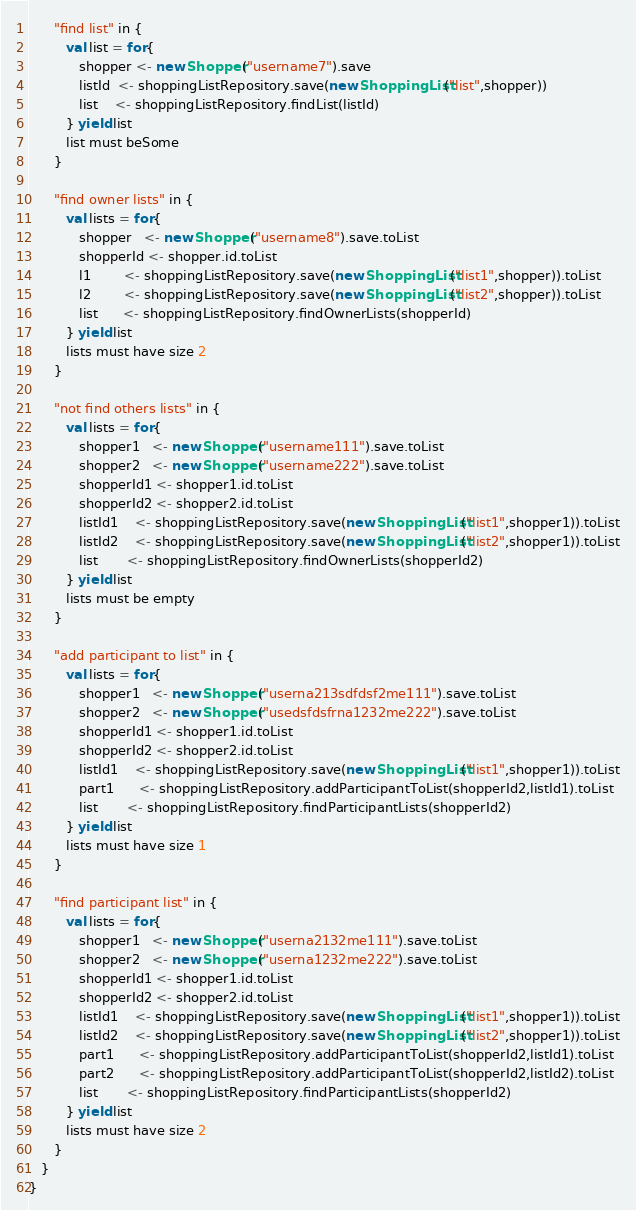<code> <loc_0><loc_0><loc_500><loc_500><_Scala_>      "find list" in {
         val list = for{
            shopper <- new Shopper("username7").save
            listId  <- shoppingListRepository.save(new ShoppingList("list",shopper))
            list    <- shoppingListRepository.findList(listId)
         } yield list
         list must beSome
      }

      "find owner lists" in {
         val lists = for{
            shopper   <- new Shopper("username8").save.toList
            shopperId <- shopper.id.toList
            l1        <- shoppingListRepository.save(new ShoppingList("list1",shopper)).toList
            l2        <- shoppingListRepository.save(new ShoppingList("list2",shopper)).toList
            list      <- shoppingListRepository.findOwnerLists(shopperId)
         } yield list
         lists must have size 2
      }

      "not find others lists" in {
         val lists = for{
            shopper1   <- new Shopper("username111").save.toList
            shopper2   <- new Shopper("username222").save.toList
            shopperId1 <- shopper1.id.toList
            shopperId2 <- shopper2.id.toList
            listId1    <- shoppingListRepository.save(new ShoppingList("list1",shopper1)).toList
            listId2    <- shoppingListRepository.save(new ShoppingList("list2",shopper1)).toList
            list       <- shoppingListRepository.findOwnerLists(shopperId2)
         } yield list
         lists must be empty
      }

      "add participant to list" in {
         val lists = for{
            shopper1   <- new Shopper("userna213sdfdsf2me111").save.toList
            shopper2   <- new Shopper("usedsfdsfrna1232me222").save.toList
            shopperId1 <- shopper1.id.toList
            shopperId2 <- shopper2.id.toList
            listId1    <- shoppingListRepository.save(new ShoppingList("list1",shopper1)).toList
            part1      <- shoppingListRepository.addParticipantToList(shopperId2,listId1).toList
            list       <- shoppingListRepository.findParticipantLists(shopperId2)
         } yield list
         lists must have size 1
      }

      "find participant list" in {
         val lists = for{
            shopper1   <- new Shopper("userna2132me111").save.toList
            shopper2   <- new Shopper("userna1232me222").save.toList
            shopperId1 <- shopper1.id.toList
            shopperId2 <- shopper2.id.toList
            listId1    <- shoppingListRepository.save(new ShoppingList("list1",shopper1)).toList
            listId2    <- shoppingListRepository.save(new ShoppingList("list2",shopper1)).toList
            part1      <- shoppingListRepository.addParticipantToList(shopperId2,listId1).toList
            part2      <- shoppingListRepository.addParticipantToList(shopperId2,listId2).toList
            list       <- shoppingListRepository.findParticipantLists(shopperId2)
         } yield list
         lists must have size 2
      }
   }
}
</code> 